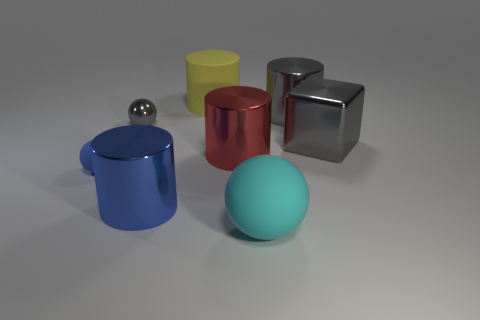Add 1 tiny metal things. How many objects exist? 9 Subtract all blue matte balls. How many balls are left? 2 Subtract 1 gray cubes. How many objects are left? 7 Subtract all balls. How many objects are left? 5 Subtract 2 balls. How many balls are left? 1 Subtract all yellow balls. Subtract all green cylinders. How many balls are left? 3 Subtract all yellow cubes. How many red cylinders are left? 1 Subtract all blue shiny things. Subtract all large yellow cylinders. How many objects are left? 6 Add 4 small gray shiny things. How many small gray shiny things are left? 5 Add 3 blue cylinders. How many blue cylinders exist? 4 